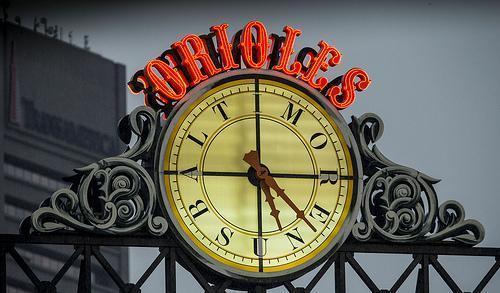How many hands are on the clock?
Give a very brief answer. 2. How many buildings are behind the clock?
Give a very brief answer. 1. 